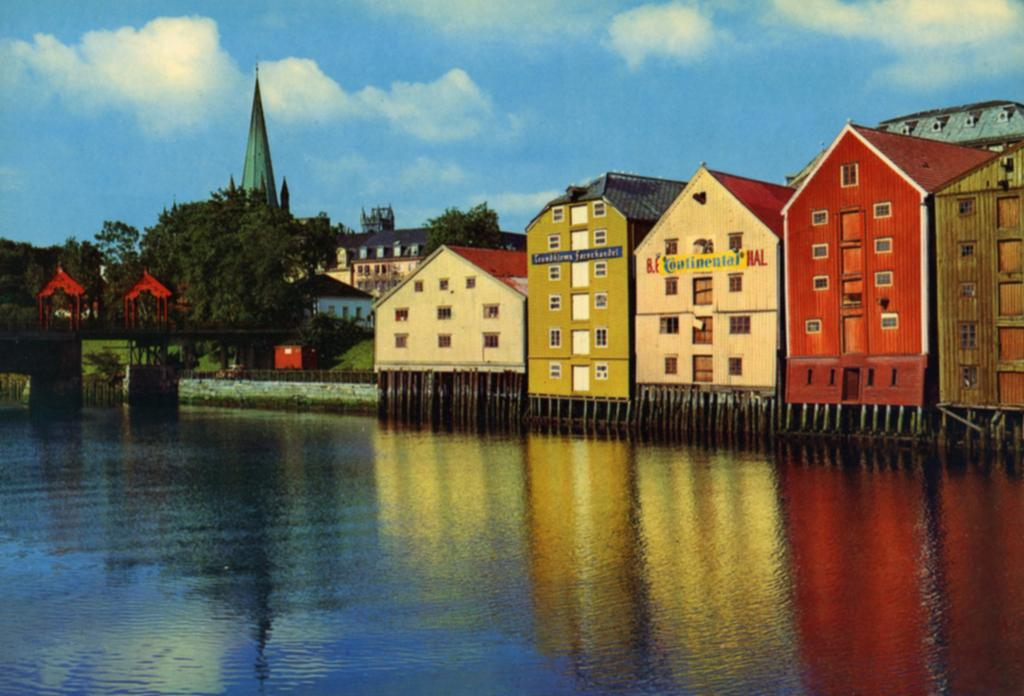What type of structures can be seen in the image? There are many buildings in the image. What is visible at the bottom of the image? There is water visible at the bottom of the image. What can be seen on the left side of the image? There is a bridge, trees, poles, and a church on the left side of the image. What is visible at the top of the image? The sky is visible at the top of the image. What can be observed in the sky? Clouds are present in the sky. What type of metal is the monkey using to climb the mountain in the image? There is no monkey or mountain present in the image. What type of metal is the bridge made of in the image? The facts provided do not specify the material of the bridge, so we cannot determine the type of metal used. 